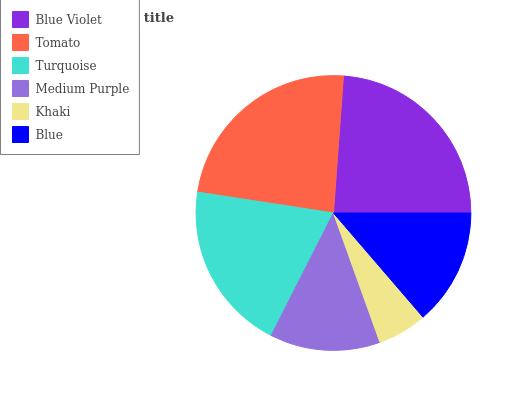Is Khaki the minimum?
Answer yes or no. Yes. Is Blue Violet the maximum?
Answer yes or no. Yes. Is Tomato the minimum?
Answer yes or no. No. Is Tomato the maximum?
Answer yes or no. No. Is Blue Violet greater than Tomato?
Answer yes or no. Yes. Is Tomato less than Blue Violet?
Answer yes or no. Yes. Is Tomato greater than Blue Violet?
Answer yes or no. No. Is Blue Violet less than Tomato?
Answer yes or no. No. Is Turquoise the high median?
Answer yes or no. Yes. Is Blue the low median?
Answer yes or no. Yes. Is Khaki the high median?
Answer yes or no. No. Is Turquoise the low median?
Answer yes or no. No. 